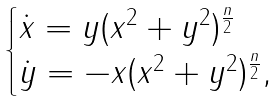Convert formula to latex. <formula><loc_0><loc_0><loc_500><loc_500>\begin{cases} \dot { x } = y ( x ^ { 2 } + y ^ { 2 } ) ^ { \frac { n } { 2 } } \\ \dot { y } = - x ( x ^ { 2 } + y ^ { 2 } ) ^ { \frac { n } { 2 } } , \end{cases}</formula> 